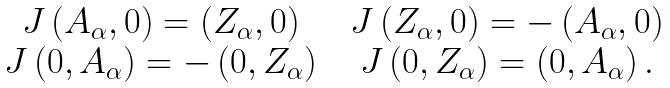Convert formula to latex. <formula><loc_0><loc_0><loc_500><loc_500>\begin{array} { c c c } J \left ( A _ { \alpha } , 0 \right ) = \left ( Z _ { \alpha } , 0 \right ) & & J \left ( Z _ { \alpha } , 0 \right ) = - \left ( A _ { \alpha } , 0 \right ) \\ J \left ( 0 , A _ { \alpha } \right ) = - \left ( 0 , Z _ { \alpha } \right ) & & J \left ( 0 , Z _ { \alpha } \right ) = \left ( 0 , A _ { \alpha } \right ) . \end{array}</formula> 